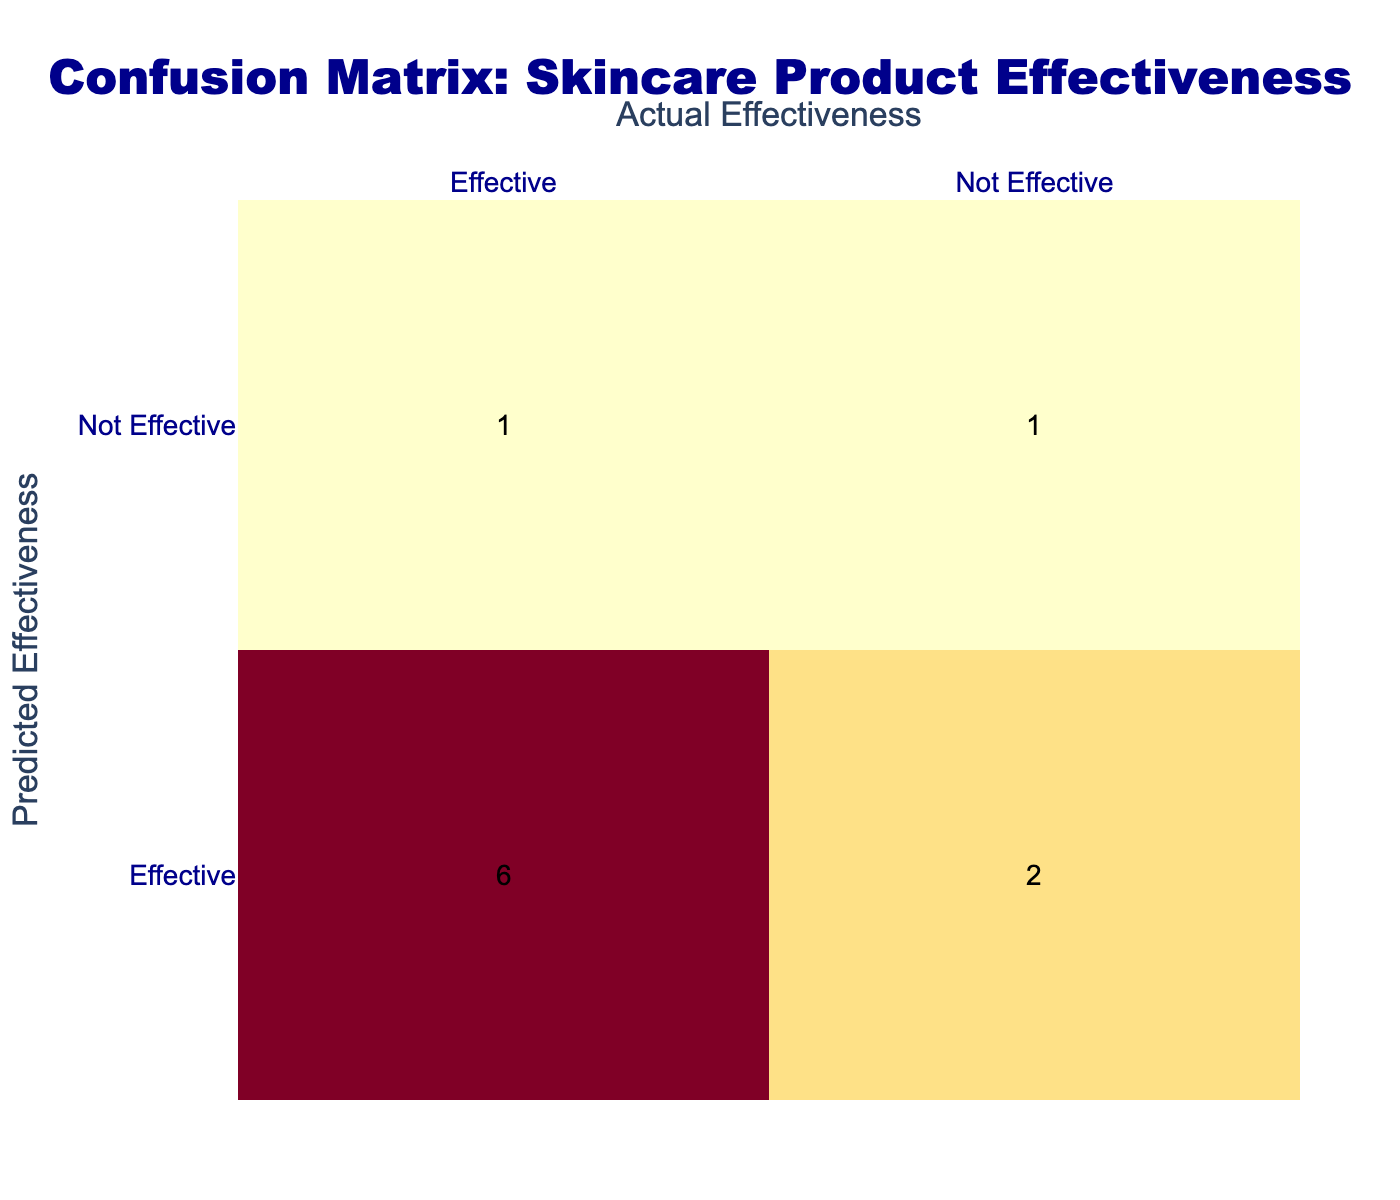What skincare product is predicted to be effective but is not? According to the table, the product "Cetaphil Gentle Skin Cleanser" is noted as "Effective" in the Predicted Effectiveness column but "Not Effective" in the Actual Effectiveness column.
Answer: Cetaphil Gentle Skin Cleanser How many products are effective according to both predicted and actual effectiveness? By examining the table, the products that are marked as "Effective" in both columns are "Neutrogena Oil-Free Acne Wash," "La Roche-Posay Effaclar Purifying Foaming Gel," "Mario Badescu Drying Lotion," "Proactiv Renewing Cleanser," and "CeraVe Foaming Facial Cleanser," totaling five products.
Answer: 5 Is the "Clinique Acne Solutions Liquid Makeup" product predicted to be effective? The table indicates that "Clinique Acne Solutions Liquid Makeup" is categorized as "Not Effective" in the Predicted Effectiveness column.
Answer: No What percentage of the products predicted to be effective were actually effective? There are 8 products predicted to be effective. Out of these, 5 were actually effective, thus the percentage is calculated as (5/8) * 100 = 62.5%.
Answer: 62.5% Which product has a false negative in the predictions? A false negative occurs when a product is predicted to be ineffective but is actually effective. "Clinique Acne Solutions Liquid Makeup" fits this description, as it is predicted to be "Not Effective" but is "Effective" in reality.
Answer: Clinique Acne Solutions Liquid Makeup How many products were both predicted and identified as not effective? The table identifies "Burt's Bees Natural Acne Solutions" as not effective in both the Predicted and Actual Effectiveness columns. This means there is just one product meeting this criterion.
Answer: 1 Among the products, which one has the highest number of mispredictions? Looking at the table, "Cetaphil Gentle Skin Cleanser" is mispredicted as effective when it is not, and "Clinique Acne Solutions Liquid Makeup" is mispredicted as not effective when it is effective. Both represent one misprediction each, but are not tested against each other; thus, each has equal misprediction counts.
Answer: Both have equal mispredictions How many products have inconsistent predictions compared to actual effectiveness? We assess the rows where predictions and actual effectiveness differ: "Cetaphil Gentle Skin Cleanser," "Clinique Acne Solutions Liquid Makeup," and "Paula's Choice CLEAR Pore Normalizing Cleanser." Therefore, there are three products with inconsistencies.
Answer: 3 